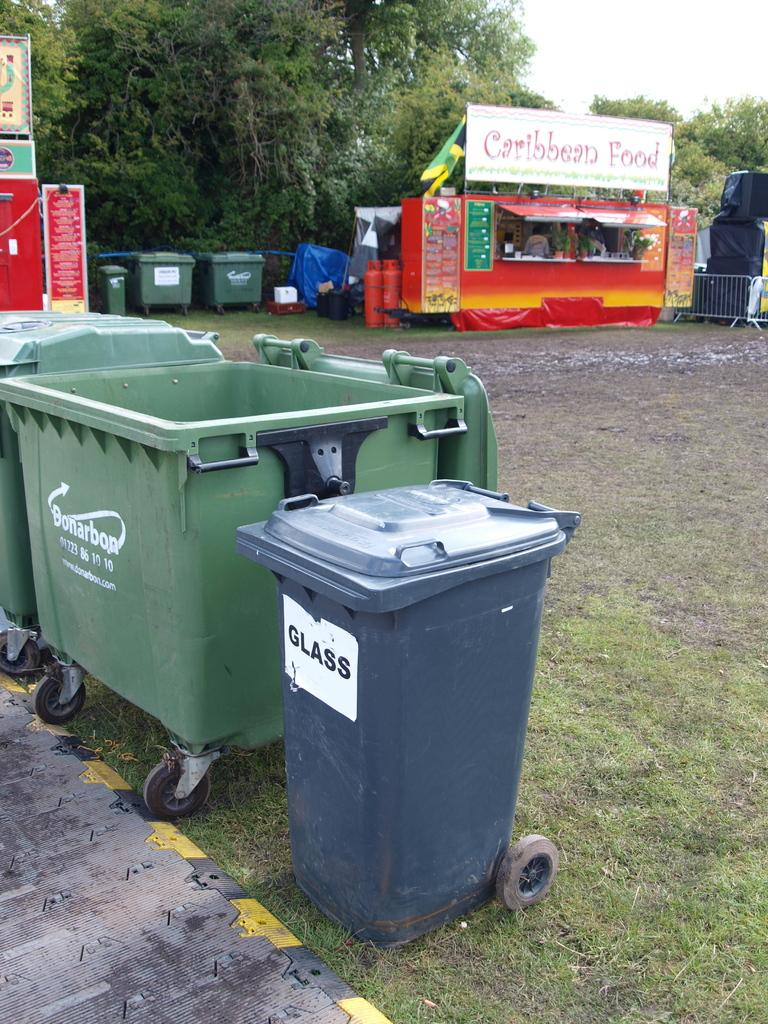<image>
Render a clear and concise summary of the photo. A stand that sells food of the Caribbean variety. 